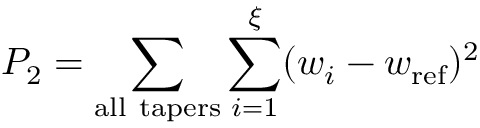<formula> <loc_0><loc_0><loc_500><loc_500>P _ { 2 } = \sum _ { a l l \ t a p e r s } \sum _ { i = 1 } ^ { \xi } ( w _ { i } - w _ { r e f } ) ^ { 2 }</formula> 